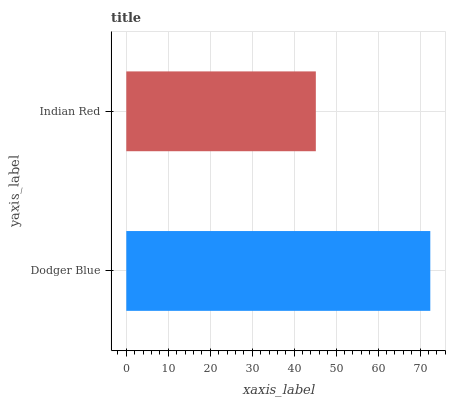Is Indian Red the minimum?
Answer yes or no. Yes. Is Dodger Blue the maximum?
Answer yes or no. Yes. Is Indian Red the maximum?
Answer yes or no. No. Is Dodger Blue greater than Indian Red?
Answer yes or no. Yes. Is Indian Red less than Dodger Blue?
Answer yes or no. Yes. Is Indian Red greater than Dodger Blue?
Answer yes or no. No. Is Dodger Blue less than Indian Red?
Answer yes or no. No. Is Dodger Blue the high median?
Answer yes or no. Yes. Is Indian Red the low median?
Answer yes or no. Yes. Is Indian Red the high median?
Answer yes or no. No. Is Dodger Blue the low median?
Answer yes or no. No. 